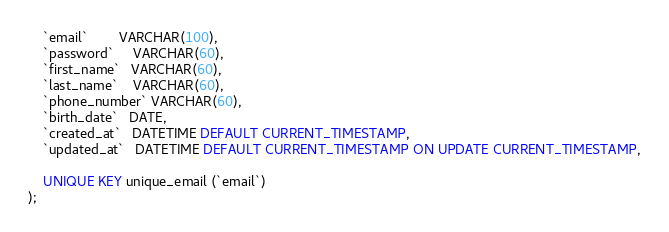<code> <loc_0><loc_0><loc_500><loc_500><_SQL_>    `email`        VARCHAR(100),
    `password`     VARCHAR(60),
    `first_name`   VARCHAR(60),
    `last_name`    VARCHAR(60),
    `phone_number` VARCHAR(60),
    `birth_date`   DATE,
    `created_at`   DATETIME DEFAULT CURRENT_TIMESTAMP,
    `updated_at`   DATETIME DEFAULT CURRENT_TIMESTAMP ON UPDATE CURRENT_TIMESTAMP,

    UNIQUE KEY unique_email (`email`)
);</code> 